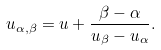<formula> <loc_0><loc_0><loc_500><loc_500>u _ { \alpha , \beta } = u + \frac { \beta - \alpha } { u _ { \beta } - u _ { \alpha } } .</formula> 